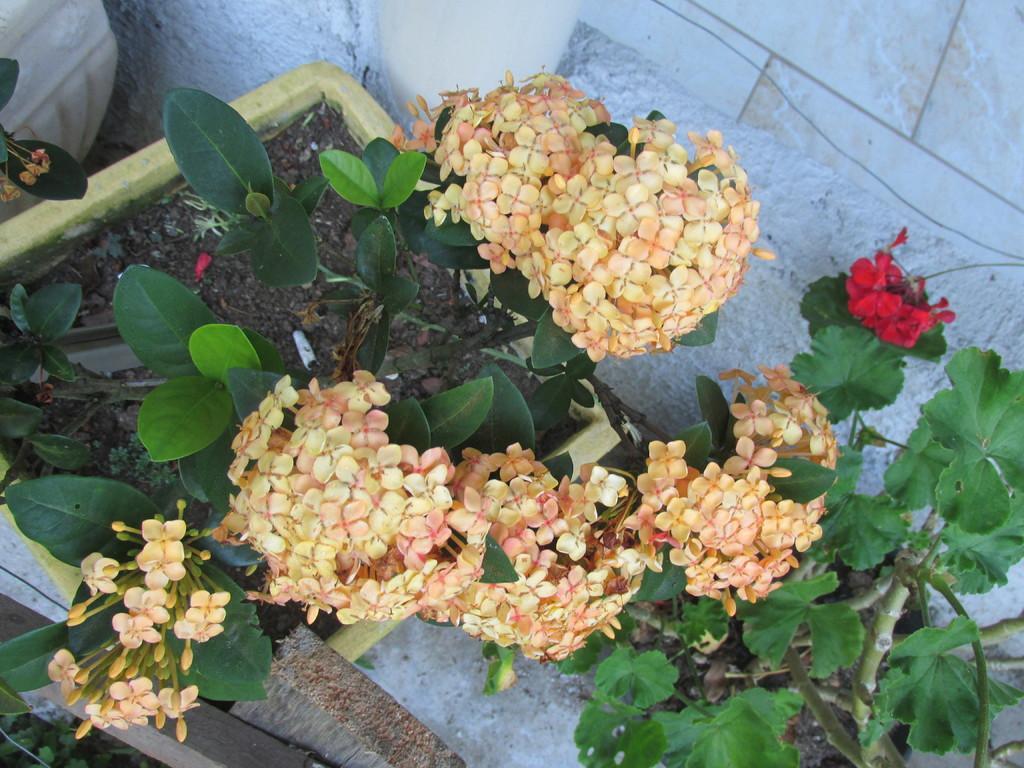Describe this image in one or two sentences. In this image there are some trees with some flowers as we can see in middle of this image and there is a wall in the background. 